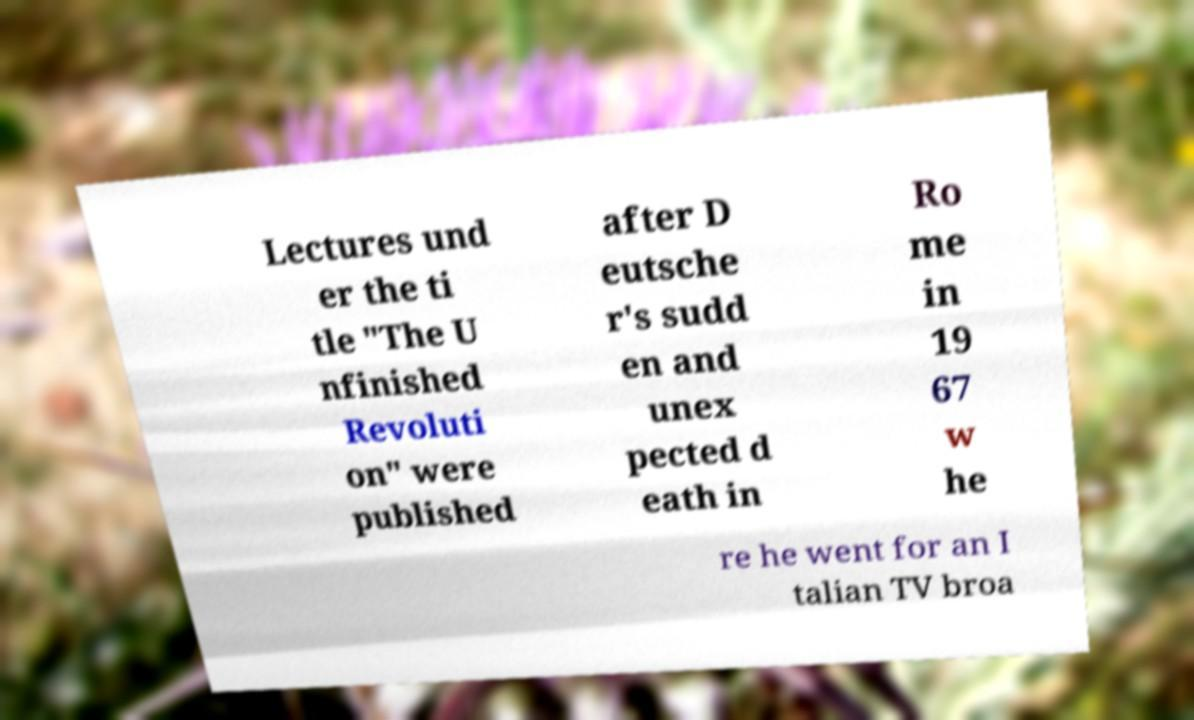For documentation purposes, I need the text within this image transcribed. Could you provide that? Lectures und er the ti tle "The U nfinished Revoluti on" were published after D eutsche r's sudd en and unex pected d eath in Ro me in 19 67 w he re he went for an I talian TV broa 